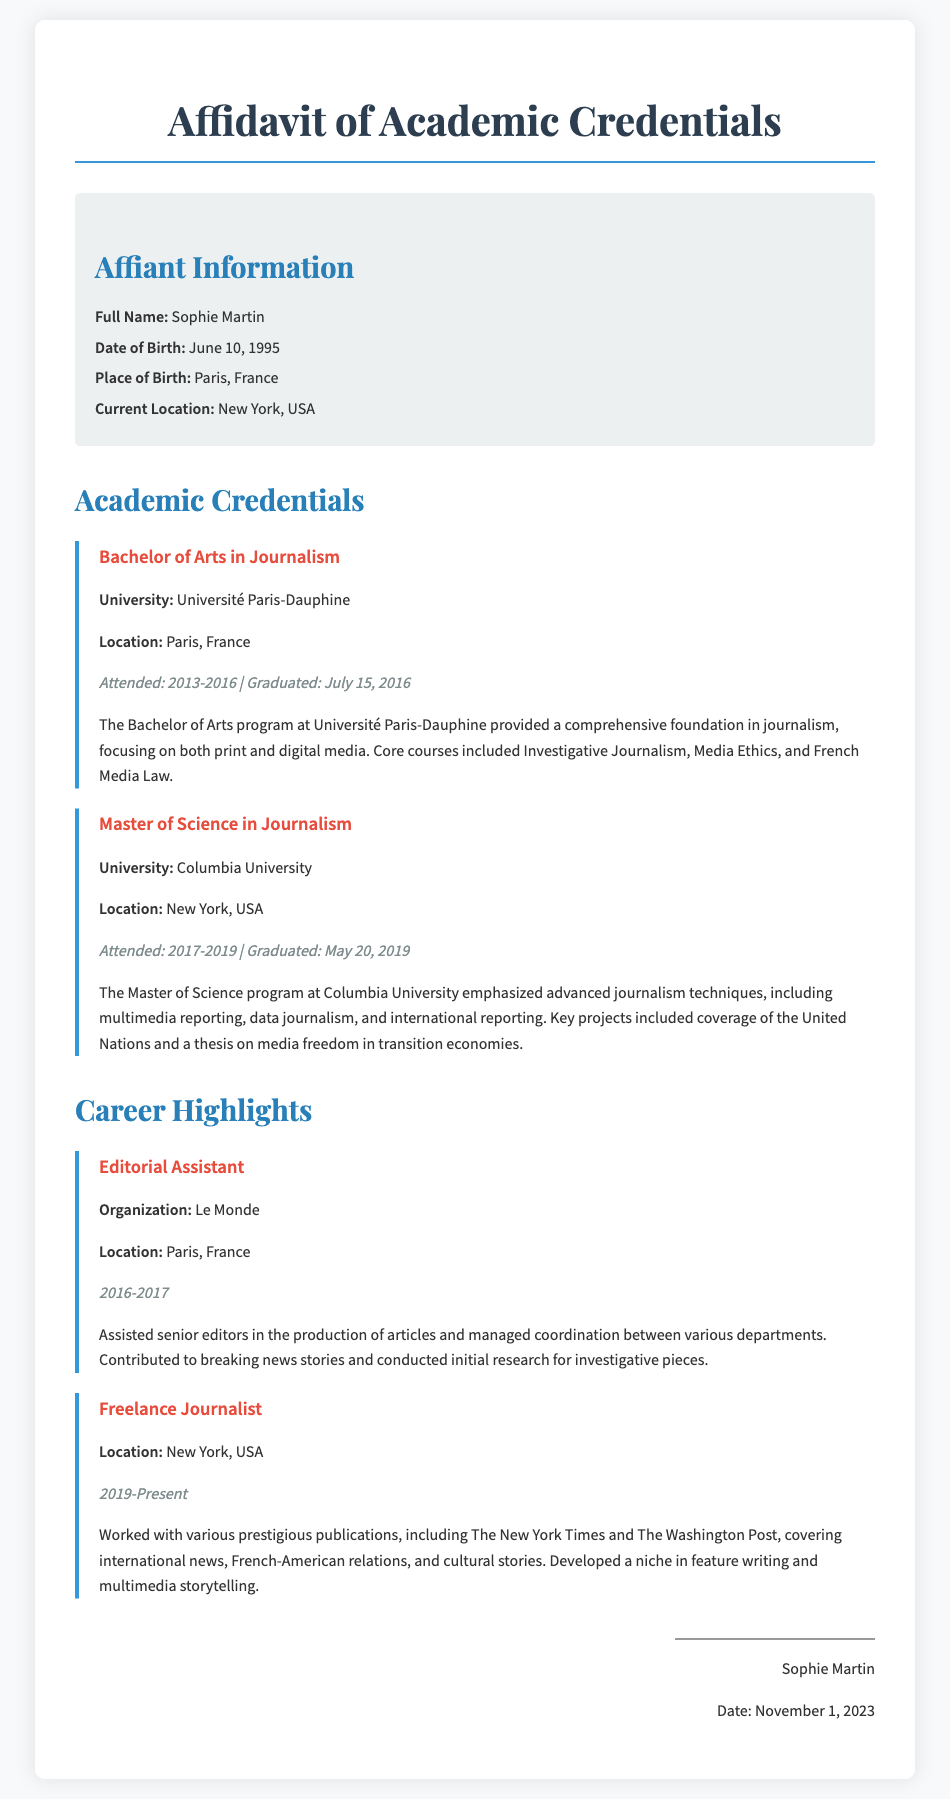What is the full name of the affiant? The full name is provided in the Affiant Information section of the document.
Answer: Sophie Martin What degree did Sophie Martin earn from Columbia University? The document specifies the academic credentials, particularly focusing on degrees earned.
Answer: Master of Science in Journalism When did Sophie Martin graduate from Université Paris-Dauphine? The graduation date is detailed in the academic credentials section for the Bachelor's degree.
Answer: July 15, 2016 What was Sophie Martin's position at Le Monde? This information is found in the Career Highlights section regarding her previous job.
Answer: Editorial Assistant How long did Sophie Martin attend Columbia University? The duration of her study is mentioned in the educational credentials.
Answer: 2017-2019 What is the current location of Sophie Martin? The current location is stated in the Affiant Information section.
Answer: New York, USA What type of projects did Sophie work on at Columbia University? The document highlights key projects in the Masters program explaining the focus areas.
Answer: Coverage of the United Nations and a thesis on media freedom What role does Sophie currently hold? The current career status is mentioned within the career highlights.
Answer: Freelance Journalist What are the core courses of Sophie’s Bachelor's program? The document details specific courses in the Bachelor’s program section.
Answer: Investigative Journalism, Media Ethics, and French Media Law 